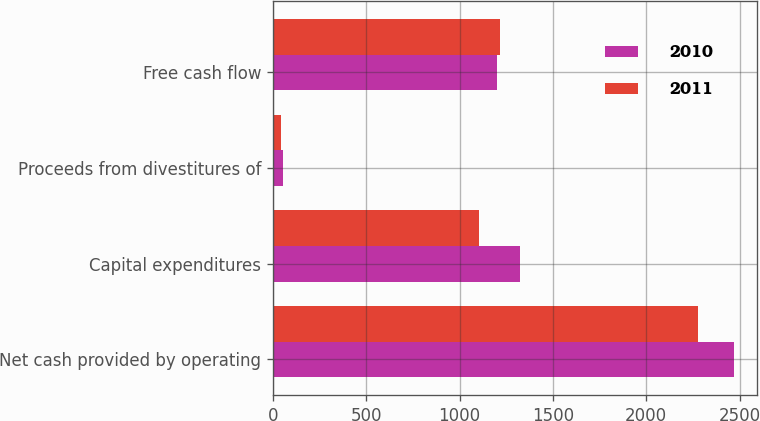Convert chart to OTSL. <chart><loc_0><loc_0><loc_500><loc_500><stacked_bar_chart><ecel><fcel>Net cash provided by operating<fcel>Capital expenditures<fcel>Proceeds from divestitures of<fcel>Free cash flow<nl><fcel>2010<fcel>2469<fcel>1324<fcel>53<fcel>1198<nl><fcel>2011<fcel>2275<fcel>1104<fcel>44<fcel>1215<nl></chart> 